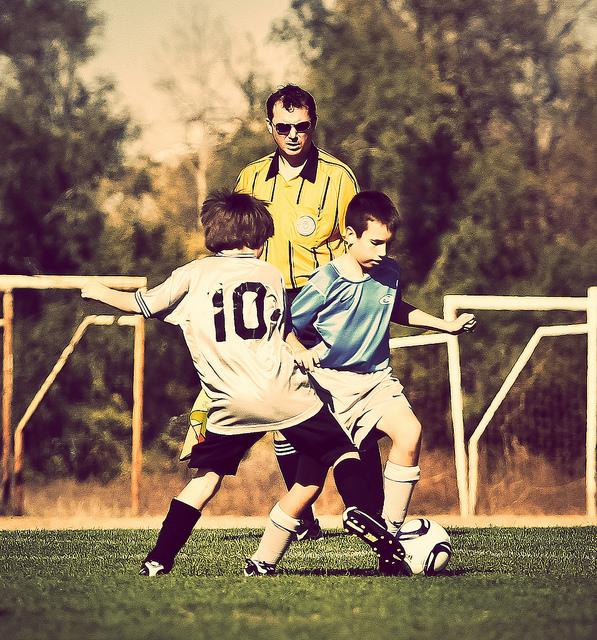What sort of job is the man standing in yellow doing? Please explain your reasoning. game official. The man is refereeing the game. 